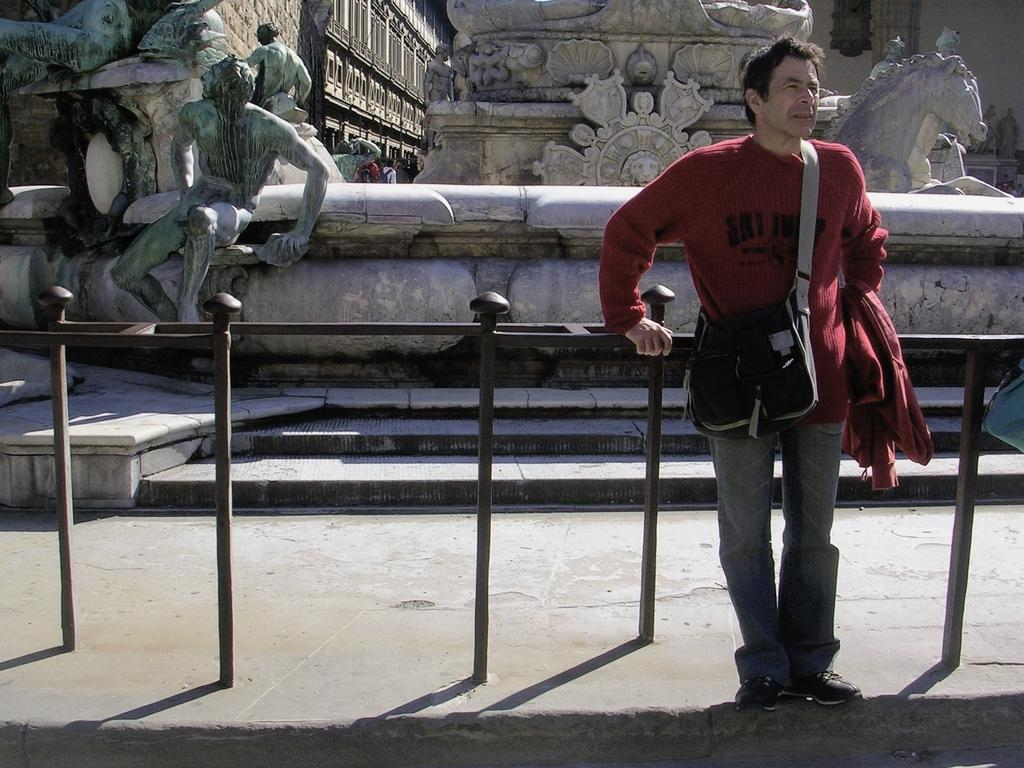What is the main subject in the foreground of the image? There is a person standing in the foreground of the image. What can be seen near the person in the image? There is a railing in the image. What type of objects are visible in the background of the image? There are sculptures in the background of the image. What is the surface that the person and railing are standing on? There is a floor visible at the bottom of the image. What type of vacation is the person planning based on the image? There is no information in the image to suggest that the person is planning a vacation. 